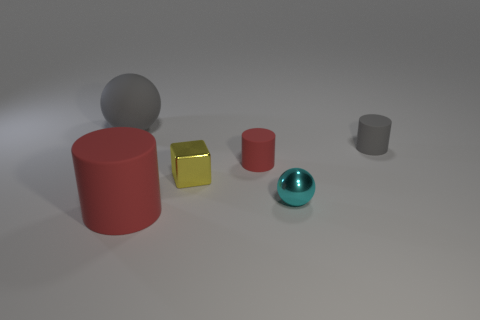Subtract all red matte cylinders. How many cylinders are left? 1 Subtract all green blocks. How many red cylinders are left? 2 Subtract all gray cylinders. How many cylinders are left? 2 Add 2 tiny cyan metal things. How many objects exist? 8 Subtract all purple cylinders. Subtract all green spheres. How many cylinders are left? 3 Subtract all metallic blocks. Subtract all large balls. How many objects are left? 4 Add 3 small gray cylinders. How many small gray cylinders are left? 4 Add 3 small yellow cubes. How many small yellow cubes exist? 4 Subtract 0 green balls. How many objects are left? 6 Subtract all spheres. How many objects are left? 4 